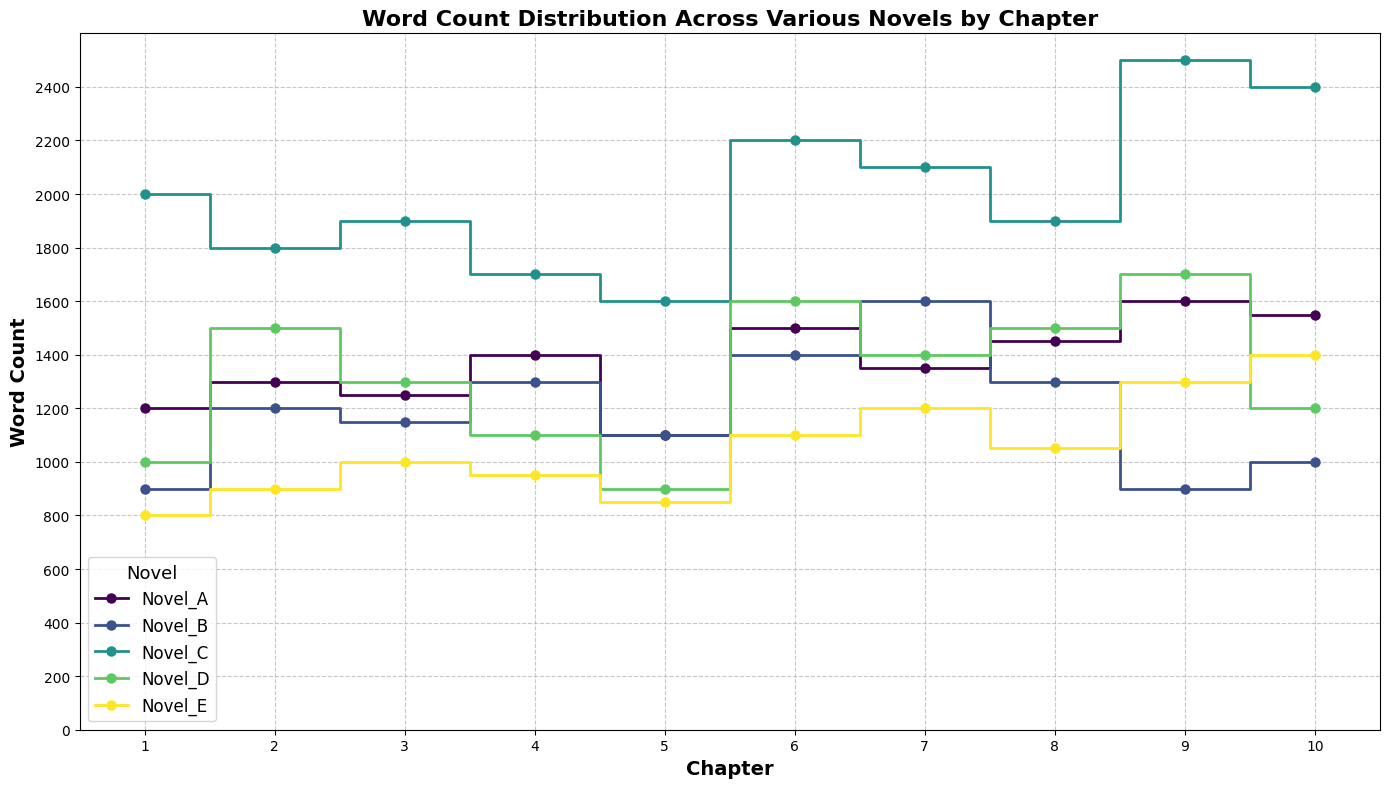What's the overall trend of word counts in Novel_A by chapter? To determine the overall trend, observe the step plot for Novel_A. Starting from Chapter 1 through Chapter 10, the word count generally increases, with some fluctuations. Chapter 5 shows a dip, and then the counts rise again, peaking around Chapter 9 before slightly dropping in Chapter 10. This indicates a general upward trend.
Answer: Increasing with fluctuations Which novel has the lowest word count in Chapter 1? Identify the lines at Chapter 1 and compare their heights. Novel_E has the lowest word count, as its step is the shortest at Chapter 1.
Answer: Novel_E What is the maximum word count achieved in any chapter across all novels? Search for the highest point in the step plots. The highest word count is 2500, reached by Novel_C in Chapter 9.
Answer: 2500 How does the word count in Chapter 5 of Novel_B compare to that of Novel_D? Locate Chapter 5 for both novels and compare the heights of the steps. Novel_B has a word count of 1100, while Novel_D has a count of 900. Novel_B's count is higher.
Answer: Novel_B is higher What's the average word count for Novel_E across all chapters? To calculate the average, sum the word counts for Novel_E (800 + 900 + 1000 + 950 + 850 + 1100 + 1200 + 1050 + 1300 + 1400) = 10550, then divide by the number of chapters, 10. The average word count is 10550/10 = 1055.
Answer: 1055 Between which chapters does Novel_C show the most significant increase in word count? Identify the chapters with the steepest ascent. The most significant increase in Novel_C occurs between Chapters 8 and 9, rising from 1900 to 2500.
Answer: Chapters 8 and 9 Compare the word counts of Novel_A and Novel_D at Chapter 6. Which one is higher? Locate Chapter 6 for both novels. Novel_A has a word count of 1500, while Novel_D has a count of 1600. Novel_D's count is higher.
Answer: Novel_D Which novel shows the most consistent word count across all chapters? Look for the novel with the least variation in step heights. Novel_E has the most consistent word count, with gradual increases and no sudden changes.
Answer: Novel_E What is the difference in word count between Chapter 10 and Chapter 1 for Novel_C? Subtract the word count of Chapter 1 (2000) from Chapter 10 (2400). The difference is 2400 - 2000 = 400.
Answer: 400 In which chapters does Novel_B have a word count below 1000? Identify the chapters where Novel_B's step heights are below 1000. These chapters are Chapter 1 (900), Chapter 9 (900), and Chapter 10 (1000, but exactly at the limit).
Answer: Chapters 1, 9, and 10 